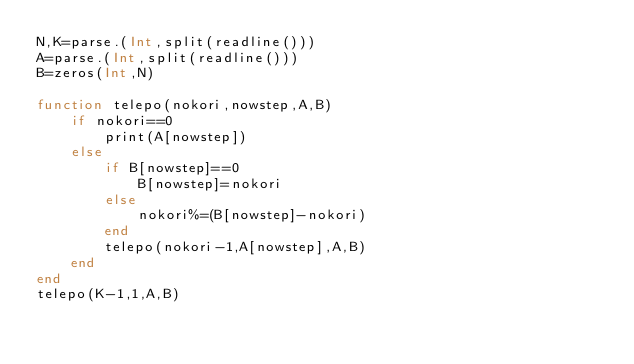Convert code to text. <code><loc_0><loc_0><loc_500><loc_500><_Julia_>N,K=parse.(Int,split(readline()))
A=parse.(Int,split(readline()))
B=zeros(Int,N)

function telepo(nokori,nowstep,A,B)
    if nokori==0
        print(A[nowstep])
    else
        if B[nowstep]==0
            B[nowstep]=nokori
        else
            nokori%=(B[nowstep]-nokori)
        end
        telepo(nokori-1,A[nowstep],A,B)
    end
end
telepo(K-1,1,A,B)</code> 